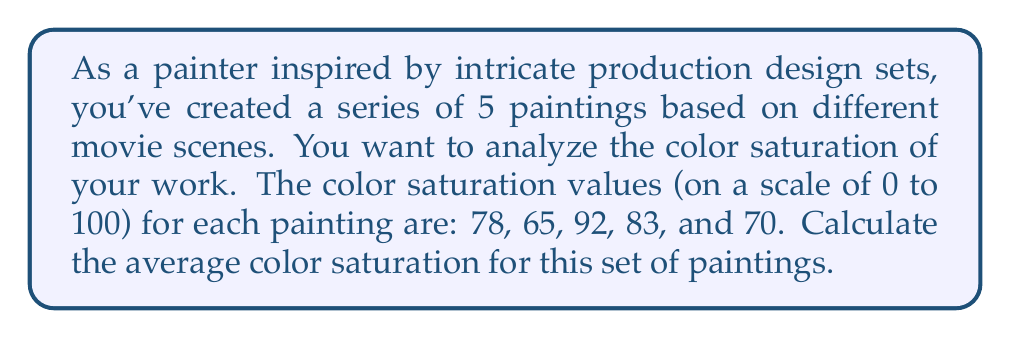Help me with this question. To calculate the average color saturation, we need to follow these steps:

1. Sum up all the saturation values:
   $$78 + 65 + 92 + 83 + 70 = 388$$

2. Count the total number of paintings:
   $$n = 5$$

3. Apply the formula for arithmetic mean (average):
   $$\text{Average} = \frac{\text{Sum of values}}{\text{Number of values}}$$

4. Substitute the values into the formula:
   $$\text{Average saturation} = \frac{388}{5}$$

5. Perform the division:
   $$\text{Average saturation} = 77.6$$

Therefore, the average color saturation for the set of paintings is 77.6 on a scale of 0 to 100.
Answer: 77.6 